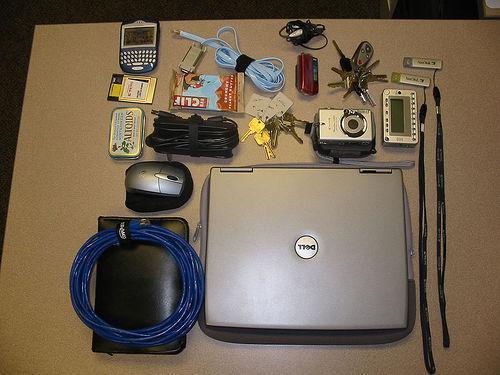How many memory sticks are shown?
Give a very brief answer. 2. How many sets of keys are shown?
Give a very brief answer. 2. How many cameras are shown?
Give a very brief answer. 1. 